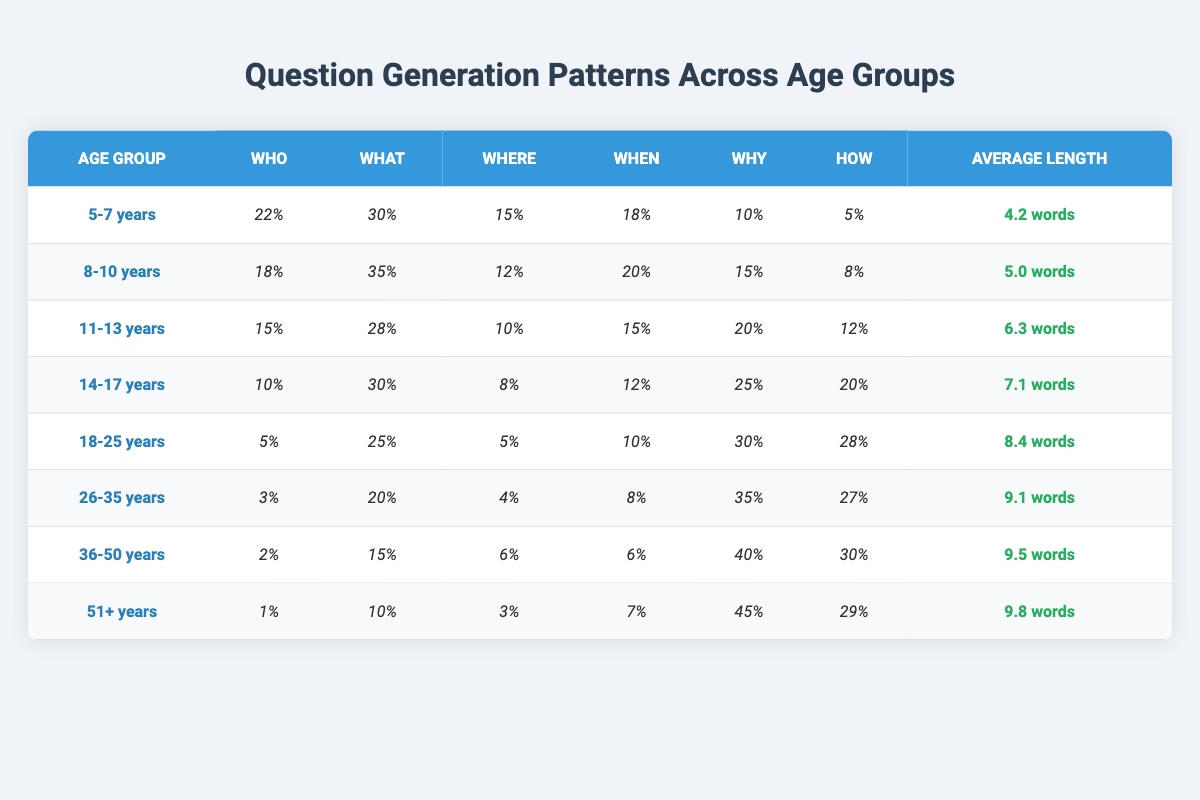What age group has the highest average question length? To find the age group with the highest average question length, we look at the "Average Length" column. By comparing the values, we see that the "51+ years" group has the highest average length of 9.8 words.
Answer: 51+ years Which age group asks the least number of "who" questions? To determine which age group asks the least number of "who" questions, we need to check the values in the "Who" column. The "51+ years" group has only 1% asking "who" questions, which is the least among all groups.
Answer: 51+ years What is the total percentage of "why" questions generated by the age groups 14-17 years and 18-25 years? To find the total percentage of "why" questions for these age groups, we sum the values: 25% (14-17 years) + 30% (18-25 years) = 55%.
Answer: 55% Is it true that the "where" questions decrease as the age group increases? We can analyze the "Where" column for each age group. The values are 15%, 12%, 10%, 8%, 5%, 4%, 6%, and 3%. This shows a general decreasing trend, so the statement is true.
Answer: Yes How many more "why" questions does the 36-50 years age group ask compared to the 26-35 years age group? From the "Why" column, the 36-50 years group has 40%, while the 26-35 years group has 35%. The difference is 40% - 35% = 5%.
Answer: 5% 